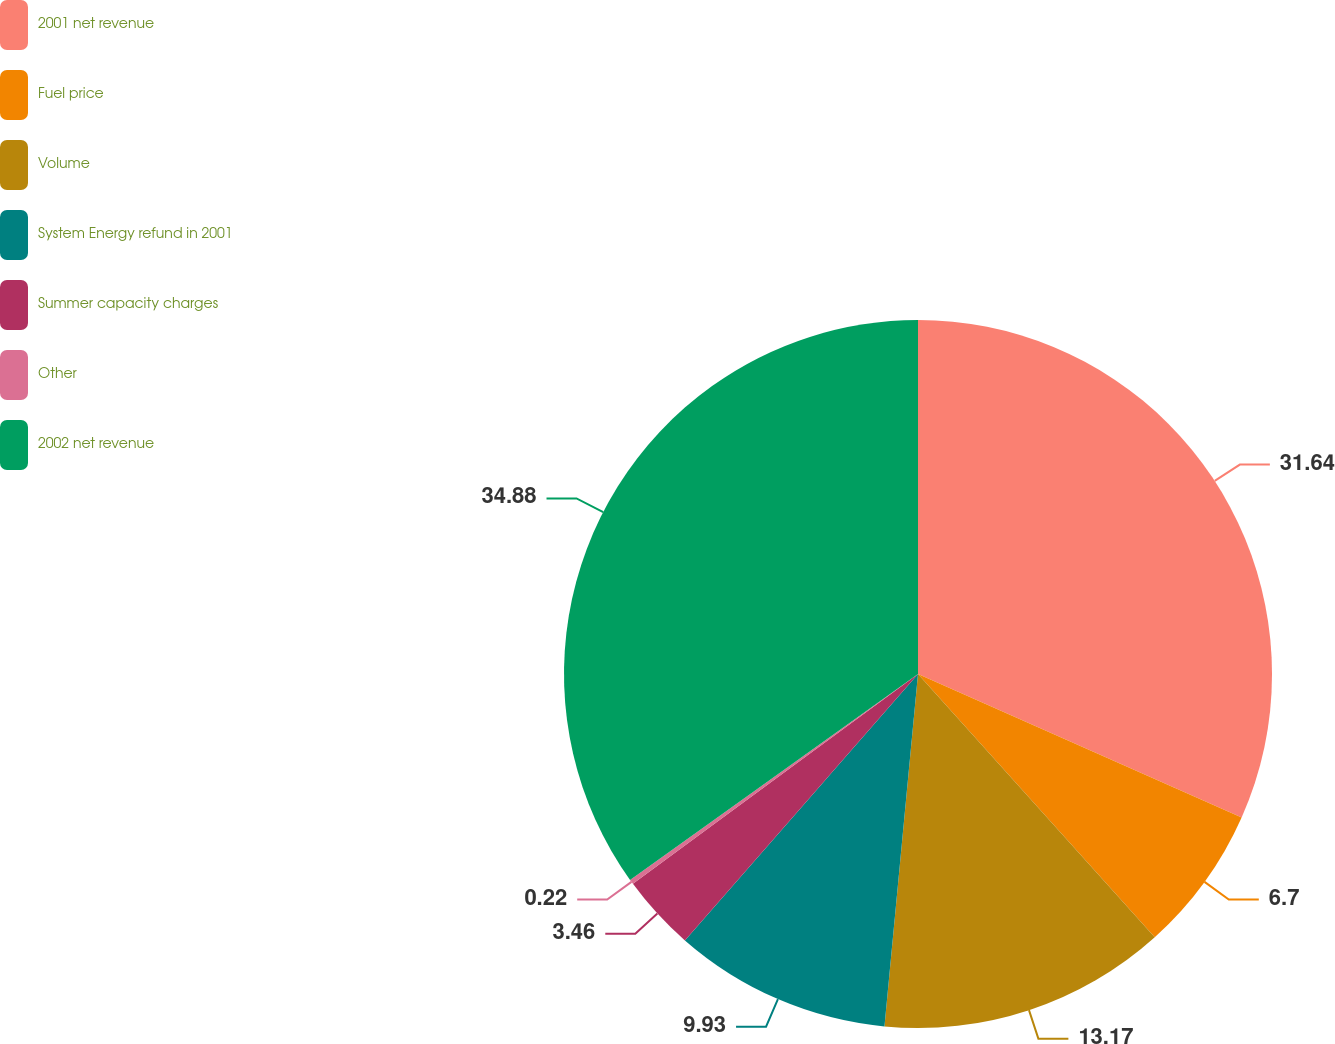<chart> <loc_0><loc_0><loc_500><loc_500><pie_chart><fcel>2001 net revenue<fcel>Fuel price<fcel>Volume<fcel>System Energy refund in 2001<fcel>Summer capacity charges<fcel>Other<fcel>2002 net revenue<nl><fcel>31.64%<fcel>6.7%<fcel>13.17%<fcel>9.93%<fcel>3.46%<fcel>0.22%<fcel>34.88%<nl></chart> 